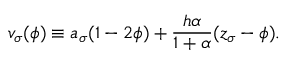Convert formula to latex. <formula><loc_0><loc_0><loc_500><loc_500>v _ { \sigma } ( \phi ) \equiv a _ { \sigma } ( 1 - 2 \phi ) + \frac { h \alpha } { 1 + \alpha } ( z _ { \sigma } - \phi ) .</formula> 